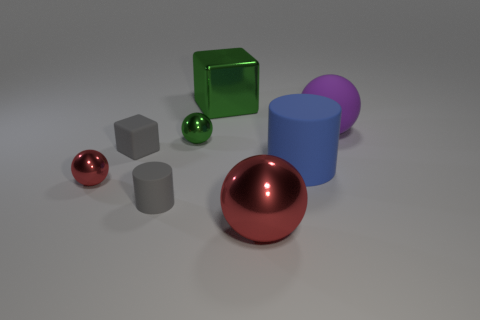There is a red shiny sphere that is on the left side of the large green object; what size is it?
Provide a succinct answer. Small. What size is the blue cylinder?
Provide a succinct answer. Large. Is the size of the gray cylinder the same as the red sphere on the left side of the tiny rubber cylinder?
Make the answer very short. Yes. There is a cylinder that is on the left side of the big rubber thing that is to the left of the purple matte ball; what color is it?
Your response must be concise. Gray. Are there an equal number of green blocks in front of the gray cube and big red shiny balls right of the blue object?
Your answer should be compact. Yes. Does the sphere that is left of the small gray block have the same material as the small gray cylinder?
Give a very brief answer. No. What color is the matte thing that is both behind the large rubber cylinder and to the left of the large red metal object?
Your answer should be compact. Gray. How many big purple things are left of the large purple matte object behind the blue thing?
Keep it short and to the point. 0. There is a tiny green object that is the same shape as the small red metal thing; what is it made of?
Your answer should be compact. Metal. What is the color of the tiny cylinder?
Your response must be concise. Gray. 